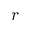Convert formula to latex. <formula><loc_0><loc_0><loc_500><loc_500>r</formula> 